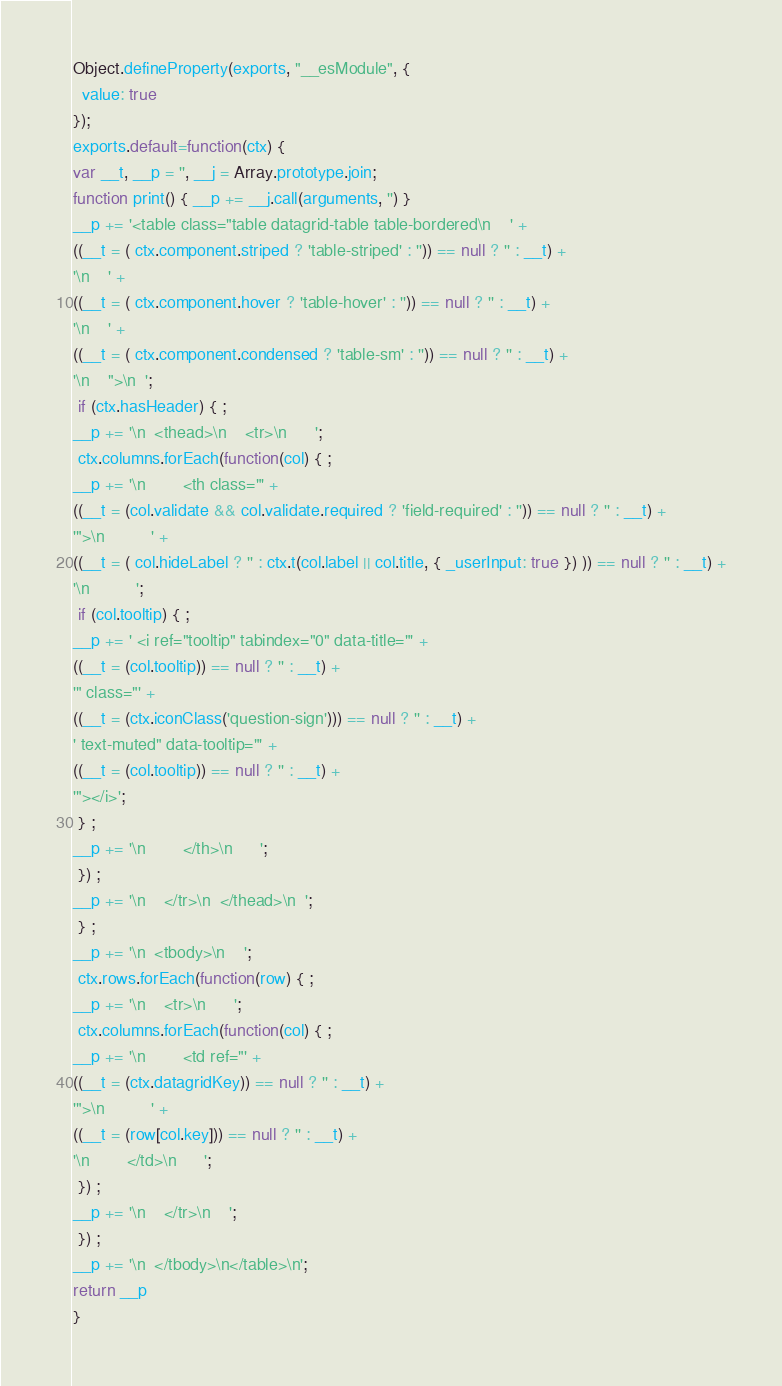<code> <loc_0><loc_0><loc_500><loc_500><_JavaScript_>Object.defineProperty(exports, "__esModule", {
  value: true
});
exports.default=function(ctx) {
var __t, __p = '', __j = Array.prototype.join;
function print() { __p += __j.call(arguments, '') }
__p += '<table class="table datagrid-table table-bordered\n    ' +
((__t = ( ctx.component.striped ? 'table-striped' : '')) == null ? '' : __t) +
'\n    ' +
((__t = ( ctx.component.hover ? 'table-hover' : '')) == null ? '' : __t) +
'\n    ' +
((__t = ( ctx.component.condensed ? 'table-sm' : '')) == null ? '' : __t) +
'\n    ">\n  ';
 if (ctx.hasHeader) { ;
__p += '\n  <thead>\n    <tr>\n      ';
 ctx.columns.forEach(function(col) { ;
__p += '\n        <th class="' +
((__t = (col.validate && col.validate.required ? 'field-required' : '')) == null ? '' : __t) +
'">\n          ' +
((__t = ( col.hideLabel ? '' : ctx.t(col.label || col.title, { _userInput: true }) )) == null ? '' : __t) +
'\n          ';
 if (col.tooltip) { ;
__p += ' <i ref="tooltip" tabindex="0" data-title="' +
((__t = (col.tooltip)) == null ? '' : __t) +
'" class="' +
((__t = (ctx.iconClass('question-sign'))) == null ? '' : __t) +
' text-muted" data-tooltip="' +
((__t = (col.tooltip)) == null ? '' : __t) +
'"></i>';
 } ;
__p += '\n        </th>\n      ';
 }) ;
__p += '\n    </tr>\n  </thead>\n  ';
 } ;
__p += '\n  <tbody>\n    ';
 ctx.rows.forEach(function(row) { ;
__p += '\n    <tr>\n      ';
 ctx.columns.forEach(function(col) { ;
__p += '\n        <td ref="' +
((__t = (ctx.datagridKey)) == null ? '' : __t) +
'">\n          ' +
((__t = (row[col.key])) == null ? '' : __t) +
'\n        </td>\n      ';
 }) ;
__p += '\n    </tr>\n    ';
 }) ;
__p += '\n  </tbody>\n</table>\n';
return __p
}</code> 